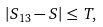Convert formula to latex. <formula><loc_0><loc_0><loc_500><loc_500>\left | S _ { 1 3 } - S \right | \leq T ,</formula> 